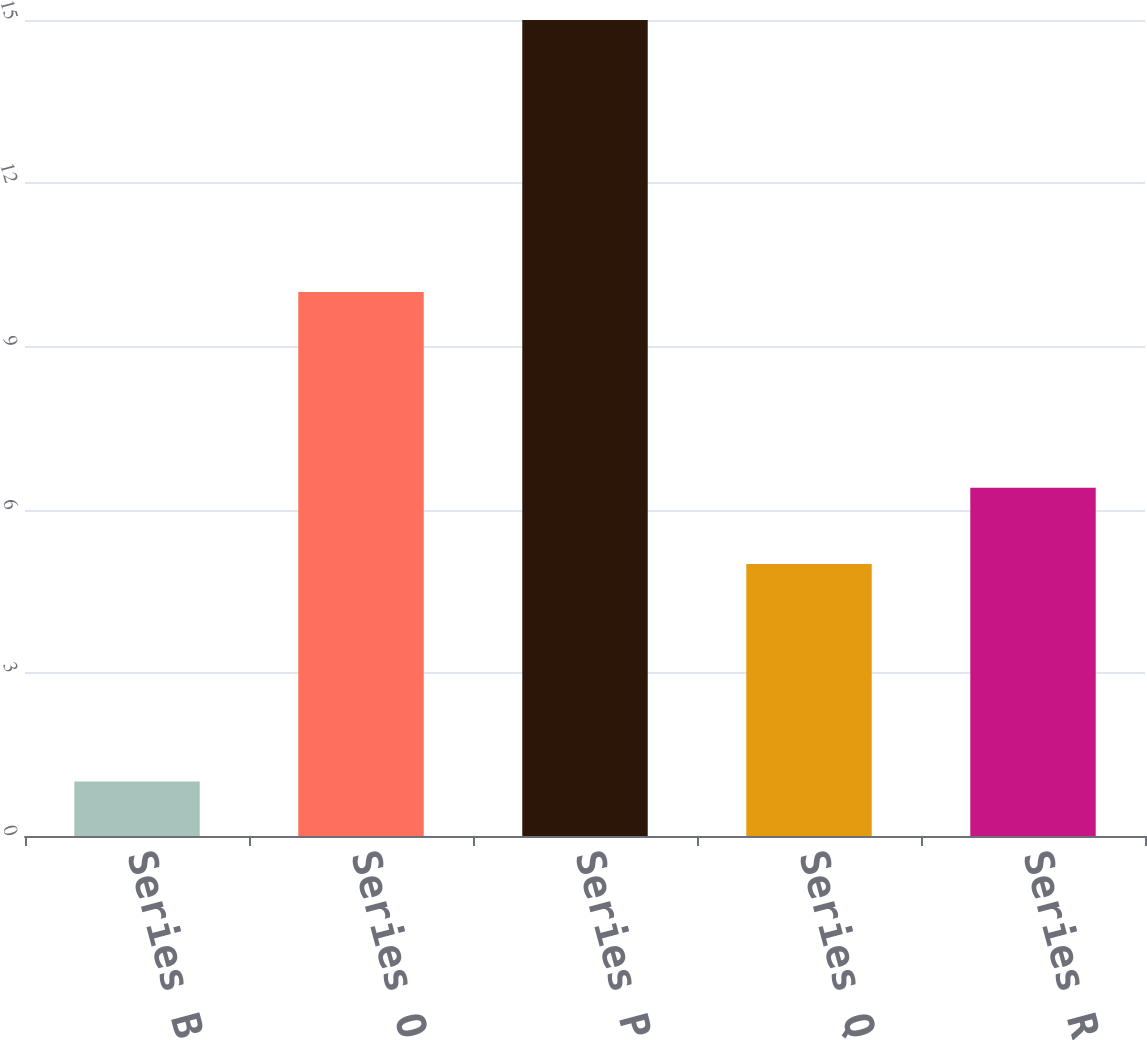Convert chart. <chart><loc_0><loc_0><loc_500><loc_500><bar_chart><fcel>Series B<fcel>Series O<fcel>Series P<fcel>Series Q<fcel>Series R<nl><fcel>1<fcel>10<fcel>15<fcel>5<fcel>6.4<nl></chart> 